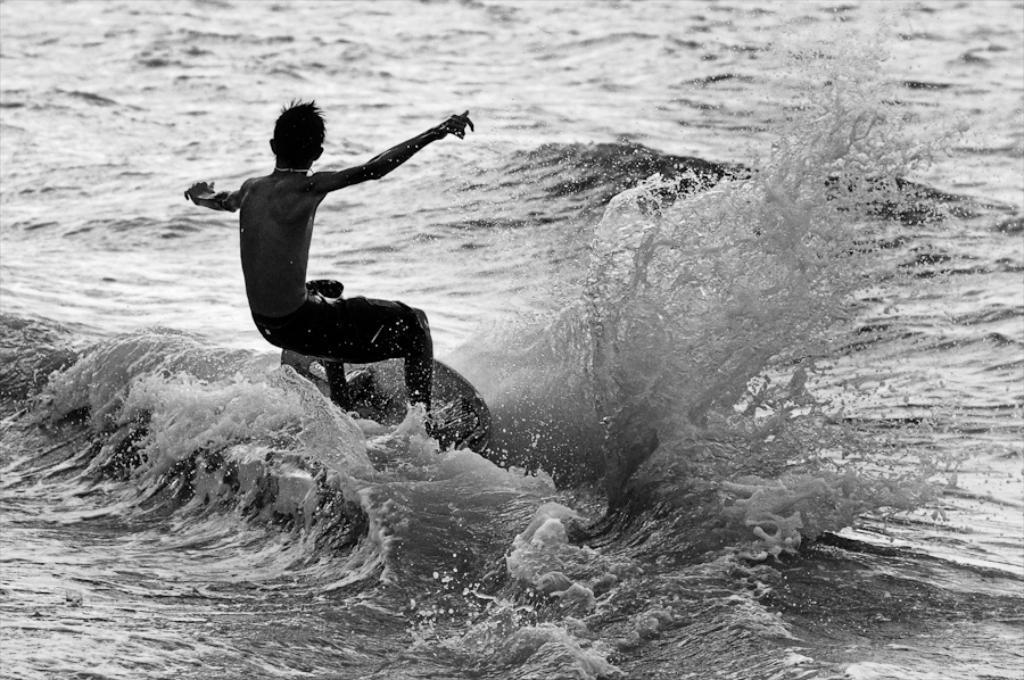Could you give a brief overview of what you see in this image? In the center of the picture there is a person surfing. In this picture there is a water body. 